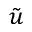Convert formula to latex. <formula><loc_0><loc_0><loc_500><loc_500>\tilde { u }</formula> 